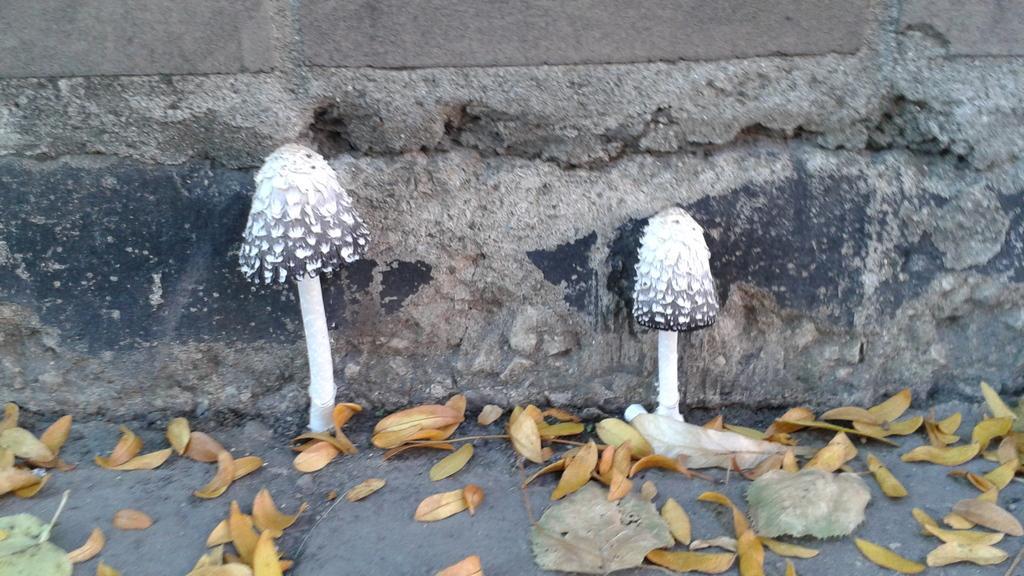Please provide a concise description of this image. In this picture we can see two mushrooms in the front, at the bottom there are some leaves, in the background we can see a wall. 